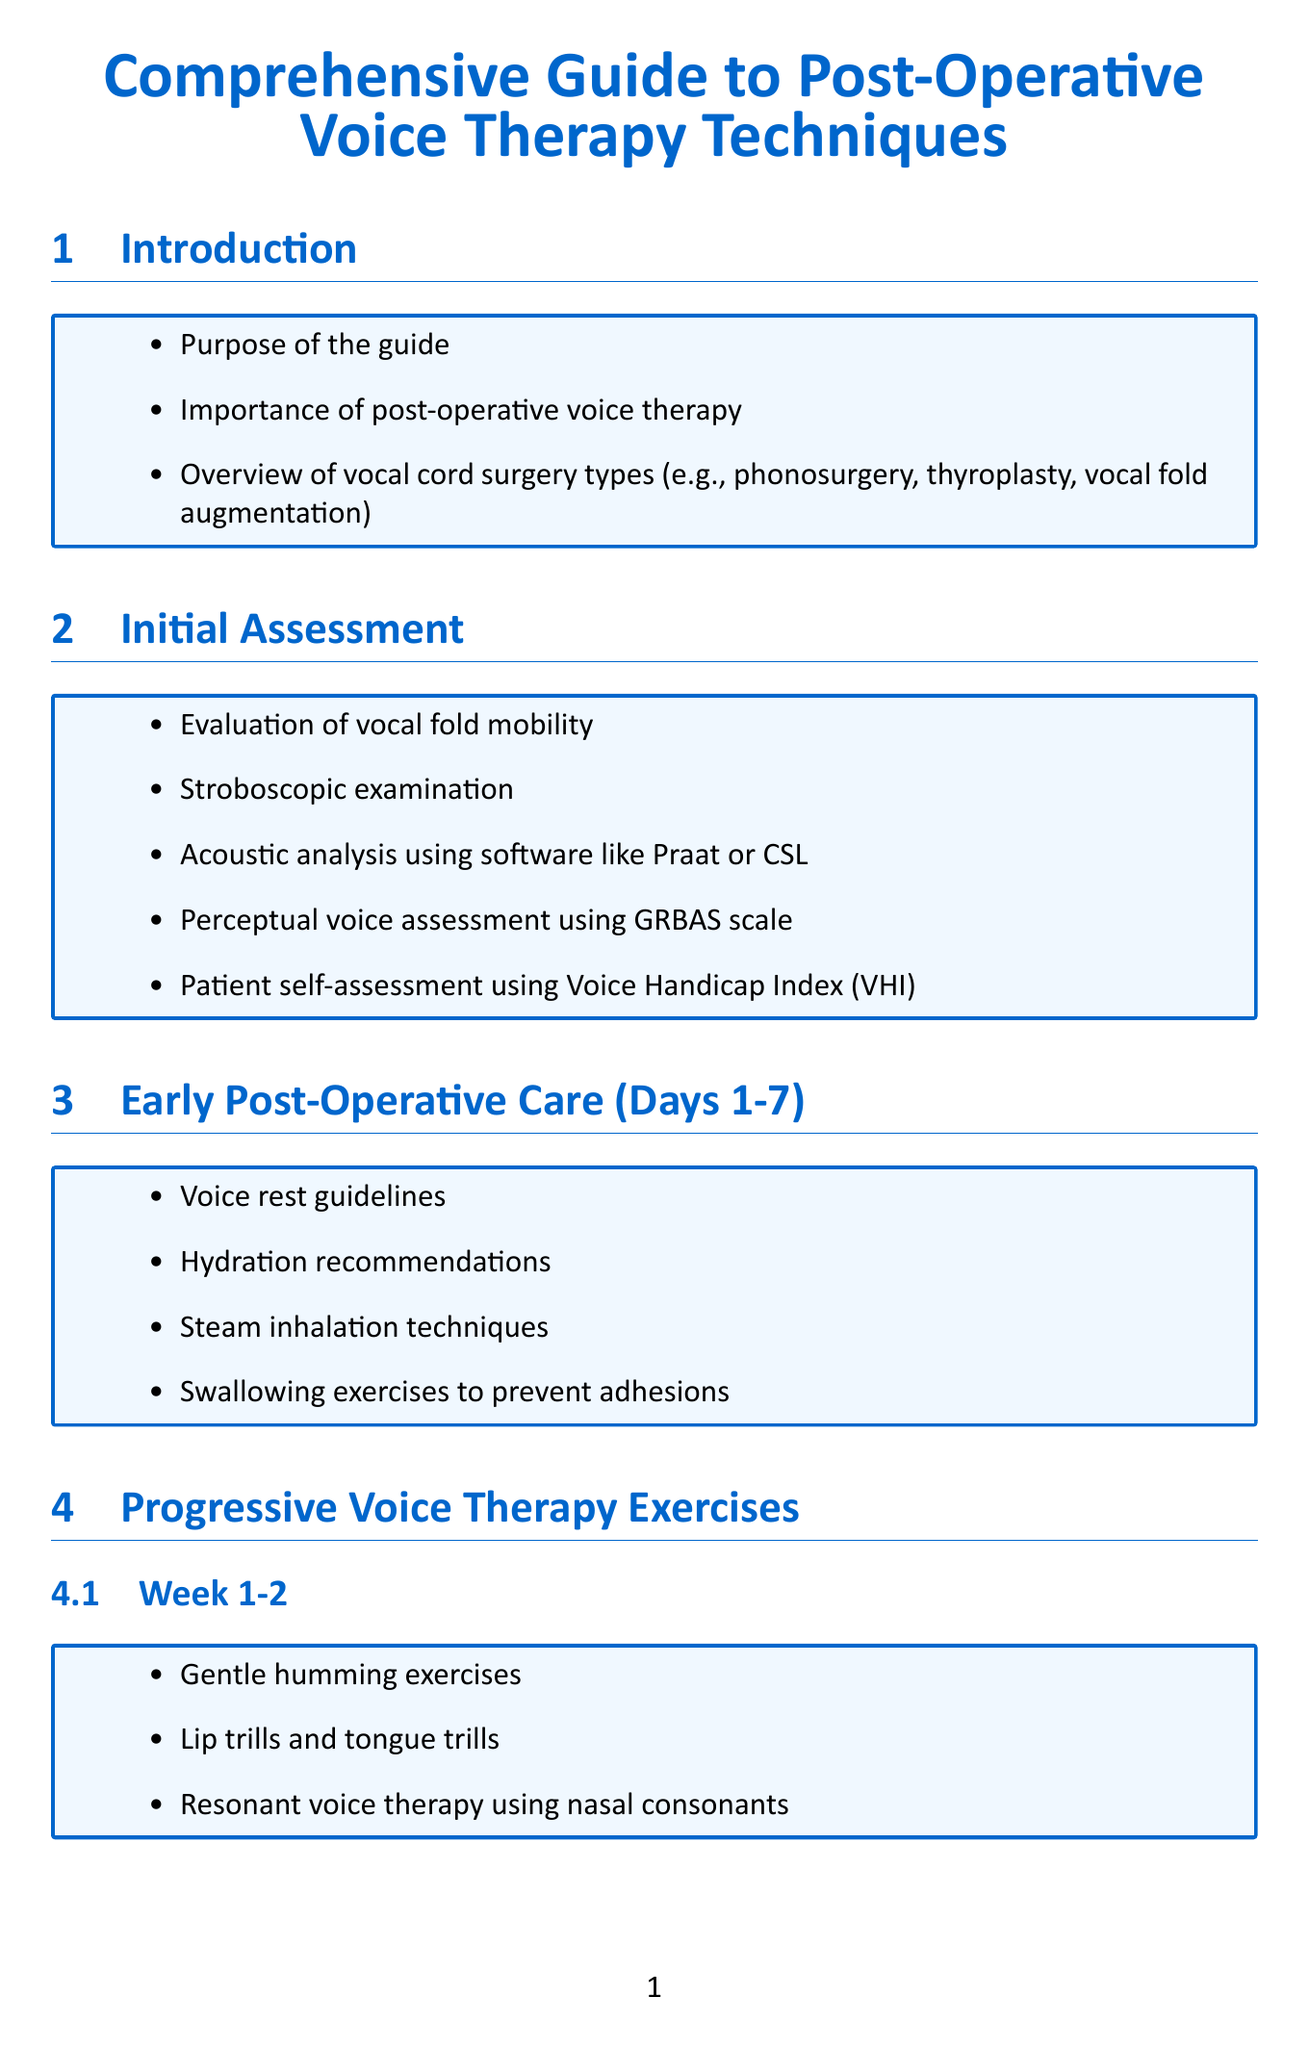What is the title of the guide? The title of the guide is clearly stated at the start of the document.
Answer: Comprehensive Guide to Post-Operative Voice Therapy Techniques Who is the patient in the recovery case study after vocal fold polyp removal? The patient is specified in the case study section, providing their name and details related to recovery.
Answer: Sarah What is the timeline for the voice rehabilitation following thyroplasty? The timeline is mentioned directly in the case studies section, summarizing the patient's recovery duration.
Answer: 6-month recovery journey What type of voice therapy exercise is suggested for weeks 3-4? The document lists specific exercises per week in the progressive voice therapy exercises section.
Answer: Semi-occluded vocal tract exercises (SOVT) What assessment is used as a patient self-assessment tool? The section on initial assessment includes various methods, including one specifically for self-evaluation by patients.
Answer: Voice Handicap Index (VHI) How often should voice recordings be taken for monitoring progress? The document provides a specific frequency for monitoring voice progress in the relevant section.
Answer: Weekly What is the main focus during the early post-operative care? The content of the early post-operative care section outlines guidelines and recommendations.
Answer: Voice rest guidelines What are the primary respiratory support techniques mentioned? The techniques are listed clearly, focusing on helping voice production post-surgery.
Answer: Diaphragmatic breathing exercises 